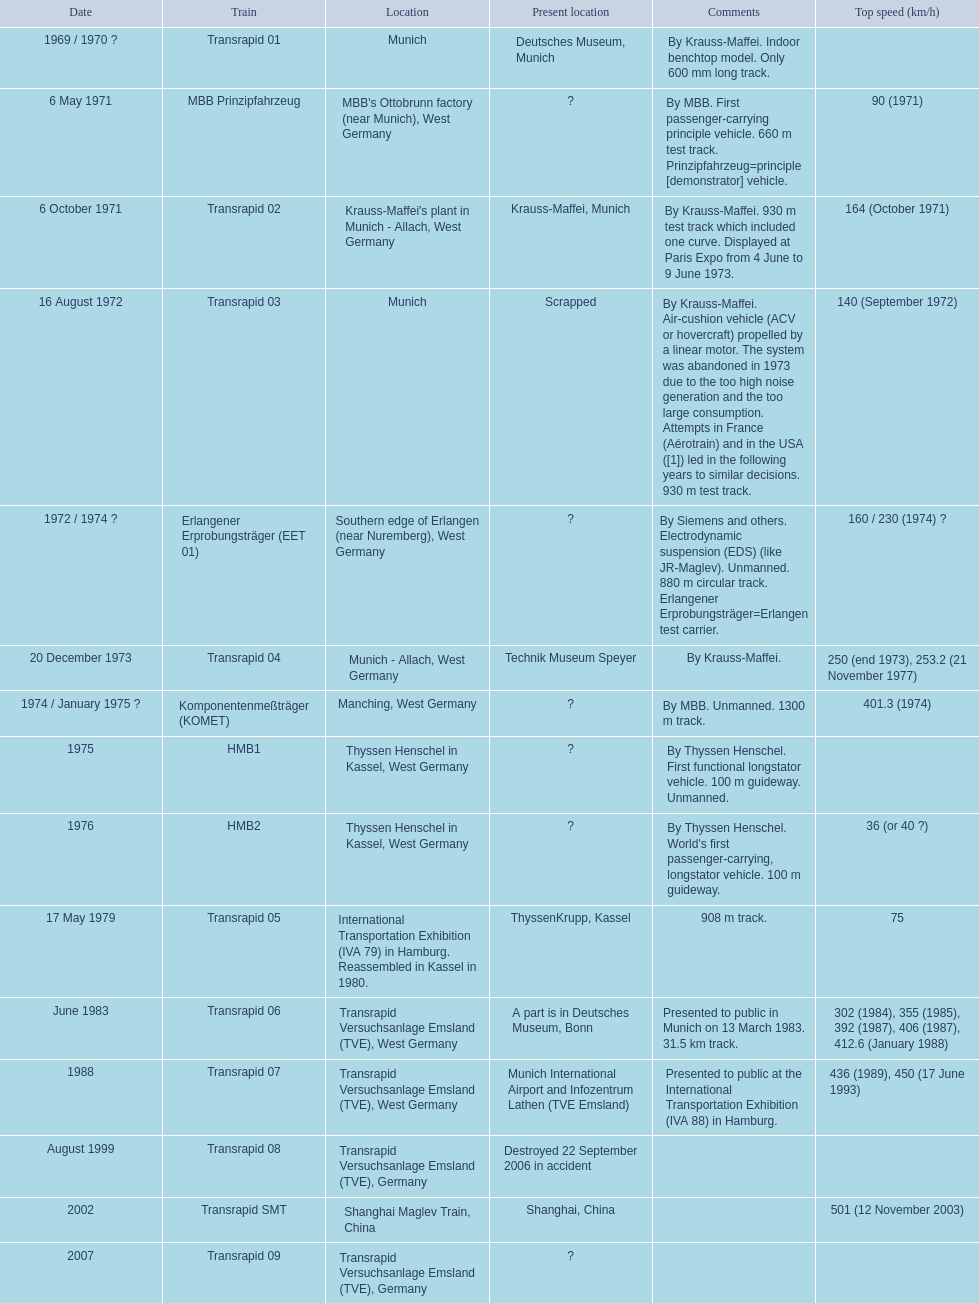Parse the table in full. {'header': ['Date', 'Train', 'Location', 'Present location', 'Comments', 'Top speed (km/h)'], 'rows': [['1969 / 1970\xa0?', 'Transrapid 01', 'Munich', 'Deutsches Museum, Munich', 'By Krauss-Maffei. Indoor benchtop model. Only 600\xa0mm long track.', ''], ['6 May 1971', 'MBB Prinzipfahrzeug', "MBB's Ottobrunn factory (near Munich), West Germany", '?', 'By MBB. First passenger-carrying principle vehicle. 660 m test track. Prinzipfahrzeug=principle [demonstrator] vehicle.', '90 (1971)'], ['6 October 1971', 'Transrapid 02', "Krauss-Maffei's plant in Munich - Allach, West Germany", 'Krauss-Maffei, Munich', 'By Krauss-Maffei. 930 m test track which included one curve. Displayed at Paris Expo from 4 June to 9 June 1973.', '164 (October 1971)'], ['16 August 1972', 'Transrapid 03', 'Munich', 'Scrapped', 'By Krauss-Maffei. Air-cushion vehicle (ACV or hovercraft) propelled by a linear motor. The system was abandoned in 1973 due to the too high noise generation and the too large consumption. Attempts in France (Aérotrain) and in the USA ([1]) led in the following years to similar decisions. 930 m test track.', '140 (September 1972)'], ['1972 / 1974\xa0?', 'Erlangener Erprobungsträger (EET 01)', 'Southern edge of Erlangen (near Nuremberg), West Germany', '?', 'By Siemens and others. Electrodynamic suspension (EDS) (like JR-Maglev). Unmanned. 880 m circular track. Erlangener Erprobungsträger=Erlangen test carrier.', '160 / 230 (1974)\xa0?'], ['20 December 1973', 'Transrapid 04', 'Munich - Allach, West Germany', 'Technik Museum Speyer', 'By Krauss-Maffei.', '250 (end 1973), 253.2 (21 November 1977)'], ['1974 / January 1975\xa0?', 'Komponentenmeßträger (KOMET)', 'Manching, West Germany', '?', 'By MBB. Unmanned. 1300 m track.', '401.3 (1974)'], ['1975', 'HMB1', 'Thyssen Henschel in Kassel, West Germany', '?', 'By Thyssen Henschel. First functional longstator vehicle. 100 m guideway. Unmanned.', ''], ['1976', 'HMB2', 'Thyssen Henschel in Kassel, West Germany', '?', "By Thyssen Henschel. World's first passenger-carrying, longstator vehicle. 100 m guideway.", '36 (or 40\xa0?)'], ['17 May 1979', 'Transrapid 05', 'International Transportation Exhibition (IVA 79) in Hamburg. Reassembled in Kassel in 1980.', 'ThyssenKrupp, Kassel', '908 m track.', '75'], ['June 1983', 'Transrapid 06', 'Transrapid Versuchsanlage Emsland (TVE), West Germany', 'A part is in Deutsches Museum, Bonn', 'Presented to public in Munich on 13 March 1983. 31.5\xa0km track.', '302 (1984), 355 (1985), 392 (1987), 406 (1987), 412.6 (January 1988)'], ['1988', 'Transrapid 07', 'Transrapid Versuchsanlage Emsland (TVE), West Germany', 'Munich International Airport and Infozentrum Lathen (TVE Emsland)', 'Presented to public at the International Transportation Exhibition (IVA 88) in Hamburg.', '436 (1989), 450 (17 June 1993)'], ['August 1999', 'Transrapid 08', 'Transrapid Versuchsanlage Emsland (TVE), Germany', 'Destroyed 22 September 2006 in accident', '', ''], ['2002', 'Transrapid SMT', 'Shanghai Maglev Train, China', 'Shanghai, China', '', '501 (12 November 2003)'], ['2007', 'Transrapid 09', 'Transrapid Versuchsanlage Emsland (TVE), Germany', '?', '', '']]} What are the designations of each transrapid train? Transrapid 01, MBB Prinzipfahrzeug, Transrapid 02, Transrapid 03, Erlangener Erprobungsträger (EET 01), Transrapid 04, Komponentenmeßträger (KOMET), HMB1, HMB2, Transrapid 05, Transrapid 06, Transrapid 07, Transrapid 08, Transrapid SMT, Transrapid 09. What are their documented maximum speeds? 90 (1971), 164 (October 1971), 140 (September 1972), 160 / 230 (1974) ?, 250 (end 1973), 253.2 (21 November 1977), 401.3 (1974), 36 (or 40 ?), 75, 302 (1984), 355 (1985), 392 (1987), 406 (1987), 412.6 (January 1988), 436 (1989), 450 (17 June 1993), 501 (12 November 2003). And which train functions at the highest speed? Transrapid SMT. 